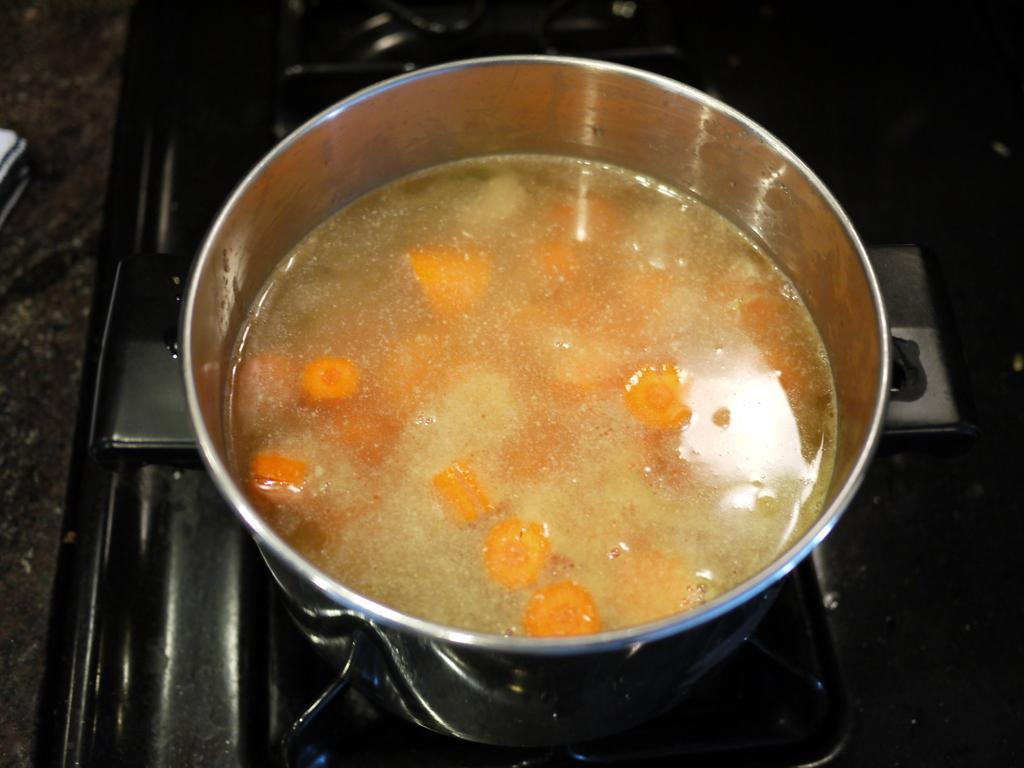What type of utensil is present in the image? There is an utensil in the image. What is inside the utensil? The utensil contains carrots and water. Where is the utensil located? The utensil is placed on a stove. What type of flowers are present in the image? There are no flowers present in the image. 